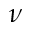Convert formula to latex. <formula><loc_0><loc_0><loc_500><loc_500>\nu</formula> 